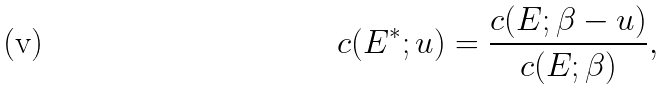<formula> <loc_0><loc_0><loc_500><loc_500>c ( E ^ { * } ; u ) = \frac { c ( E ; \beta - u ) } { c ( E ; \beta ) } ,</formula> 